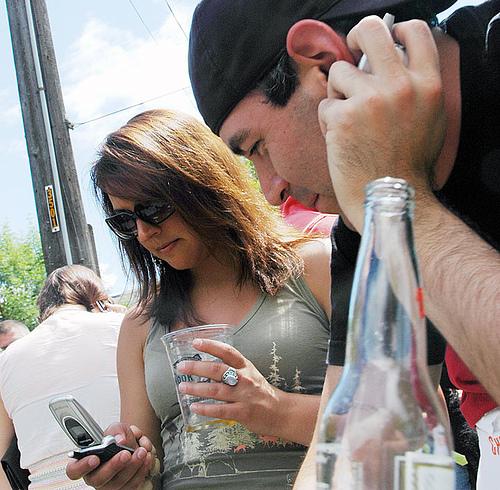Is the woman wearing a ring?
Concise answer only. Yes. What does the woman have in her right hand?
Short answer required. Cell phone. Is the man wearing a hat?
Quick response, please. Yes. 